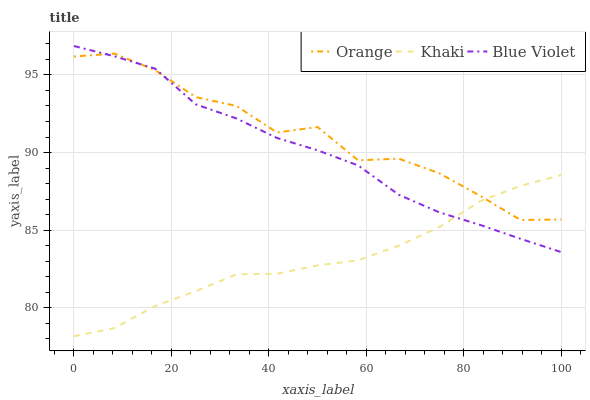Does Khaki have the minimum area under the curve?
Answer yes or no. Yes. Does Orange have the maximum area under the curve?
Answer yes or no. Yes. Does Blue Violet have the minimum area under the curve?
Answer yes or no. No. Does Blue Violet have the maximum area under the curve?
Answer yes or no. No. Is Khaki the smoothest?
Answer yes or no. Yes. Is Orange the roughest?
Answer yes or no. Yes. Is Blue Violet the smoothest?
Answer yes or no. No. Is Blue Violet the roughest?
Answer yes or no. No. Does Khaki have the lowest value?
Answer yes or no. Yes. Does Blue Violet have the lowest value?
Answer yes or no. No. Does Blue Violet have the highest value?
Answer yes or no. Yes. Does Khaki have the highest value?
Answer yes or no. No. Does Khaki intersect Blue Violet?
Answer yes or no. Yes. Is Khaki less than Blue Violet?
Answer yes or no. No. Is Khaki greater than Blue Violet?
Answer yes or no. No. 